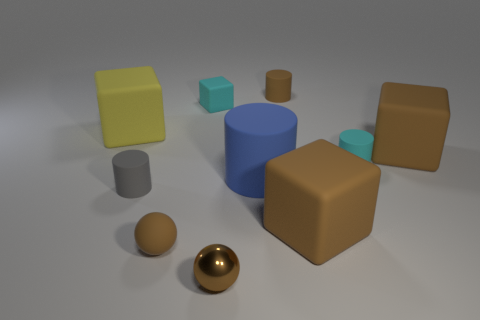Subtract all yellow balls. How many brown blocks are left? 2 Subtract all large blue cylinders. How many cylinders are left? 3 Subtract all blue cylinders. How many cylinders are left? 3 Subtract 2 cubes. How many cubes are left? 2 Subtract all balls. How many objects are left? 8 Subtract all purple cubes. Subtract all brown cylinders. How many cubes are left? 4 Add 8 tiny spheres. How many tiny spheres are left? 10 Add 2 small yellow matte objects. How many small yellow matte objects exist? 2 Subtract 1 blue cylinders. How many objects are left? 9 Subtract all tiny cubes. Subtract all rubber cubes. How many objects are left? 5 